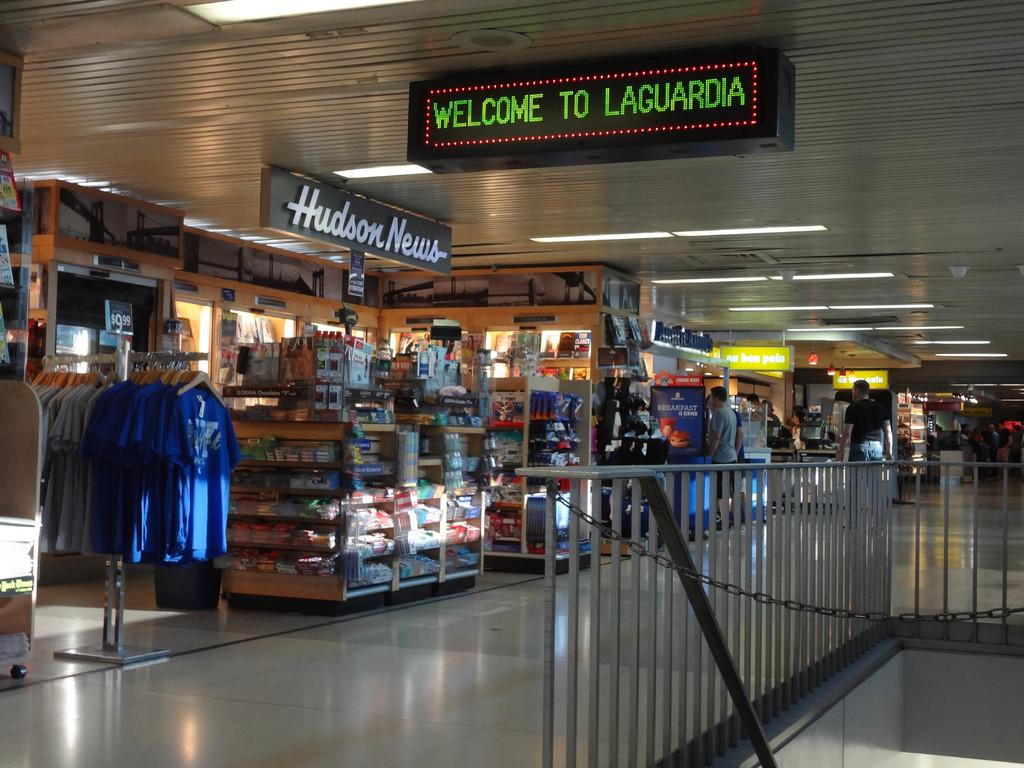<image>
Relay a brief, clear account of the picture shown. A lighted sign in green reads Welcome to Laguardia. 